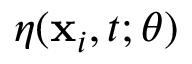<formula> <loc_0><loc_0><loc_500><loc_500>\eta ( x _ { i } , t ; \theta )</formula> 